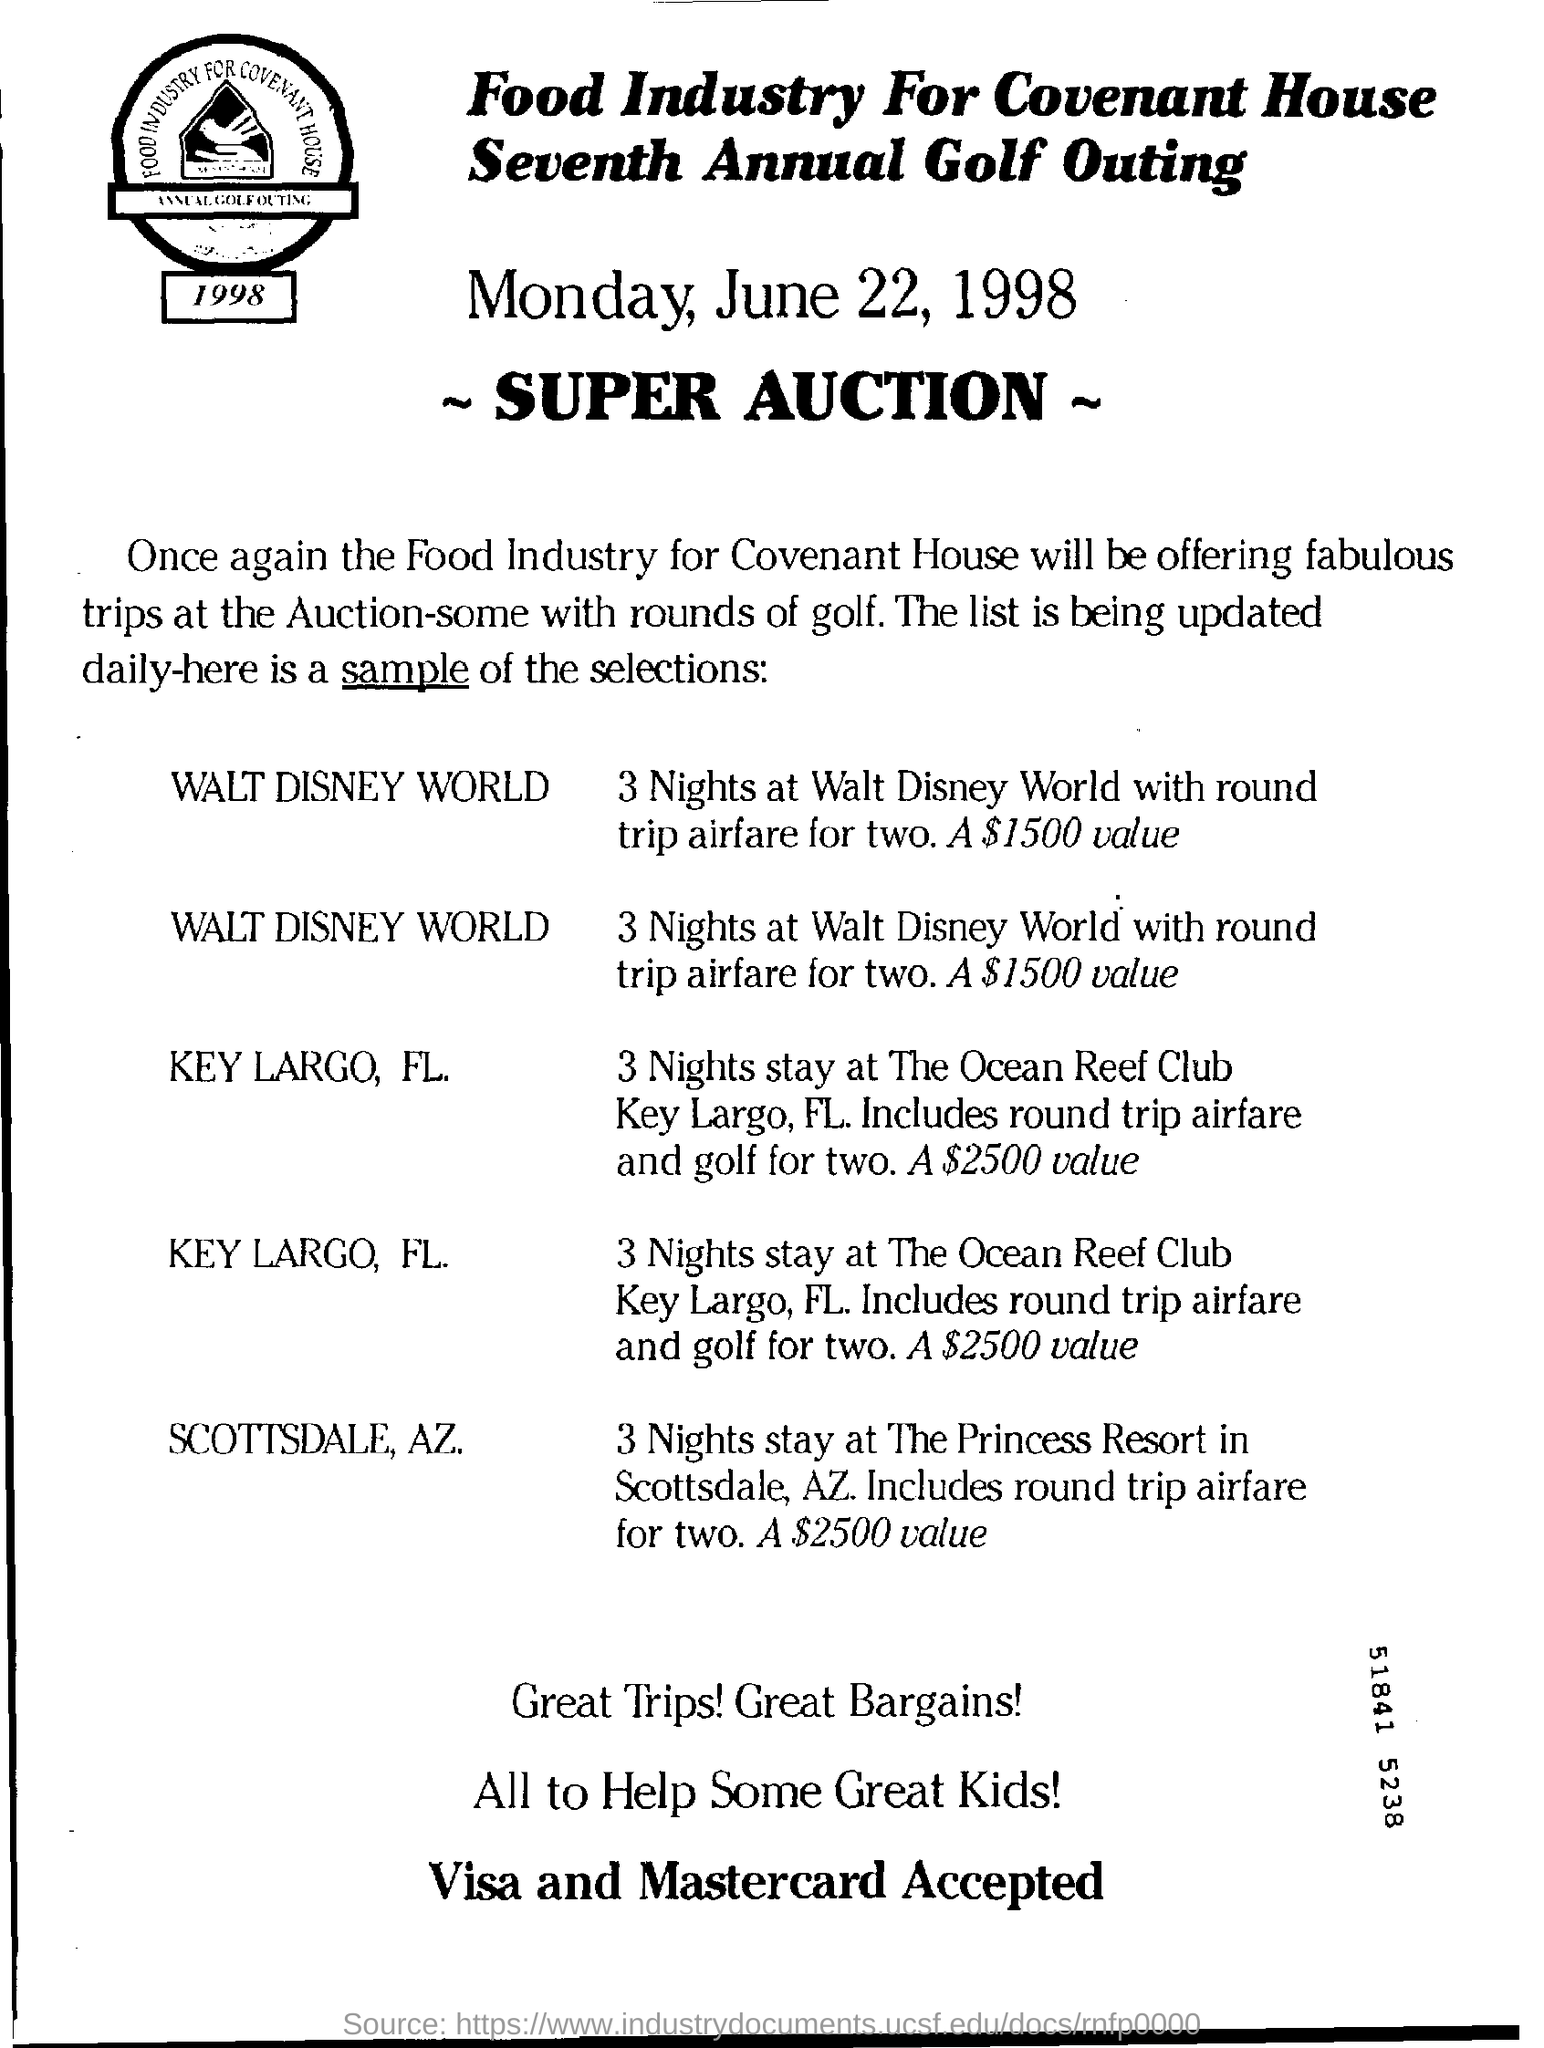When will the super auction be held?
Offer a terse response. Monday, June 22, 1998. What is the value for 3 nights at Walt Disney World with round trip airfare for two?
Offer a terse response. $1500. Who is organizing the Seventh Annual Golf Outing?
Give a very brief answer. Food Industry for Covenant House. 